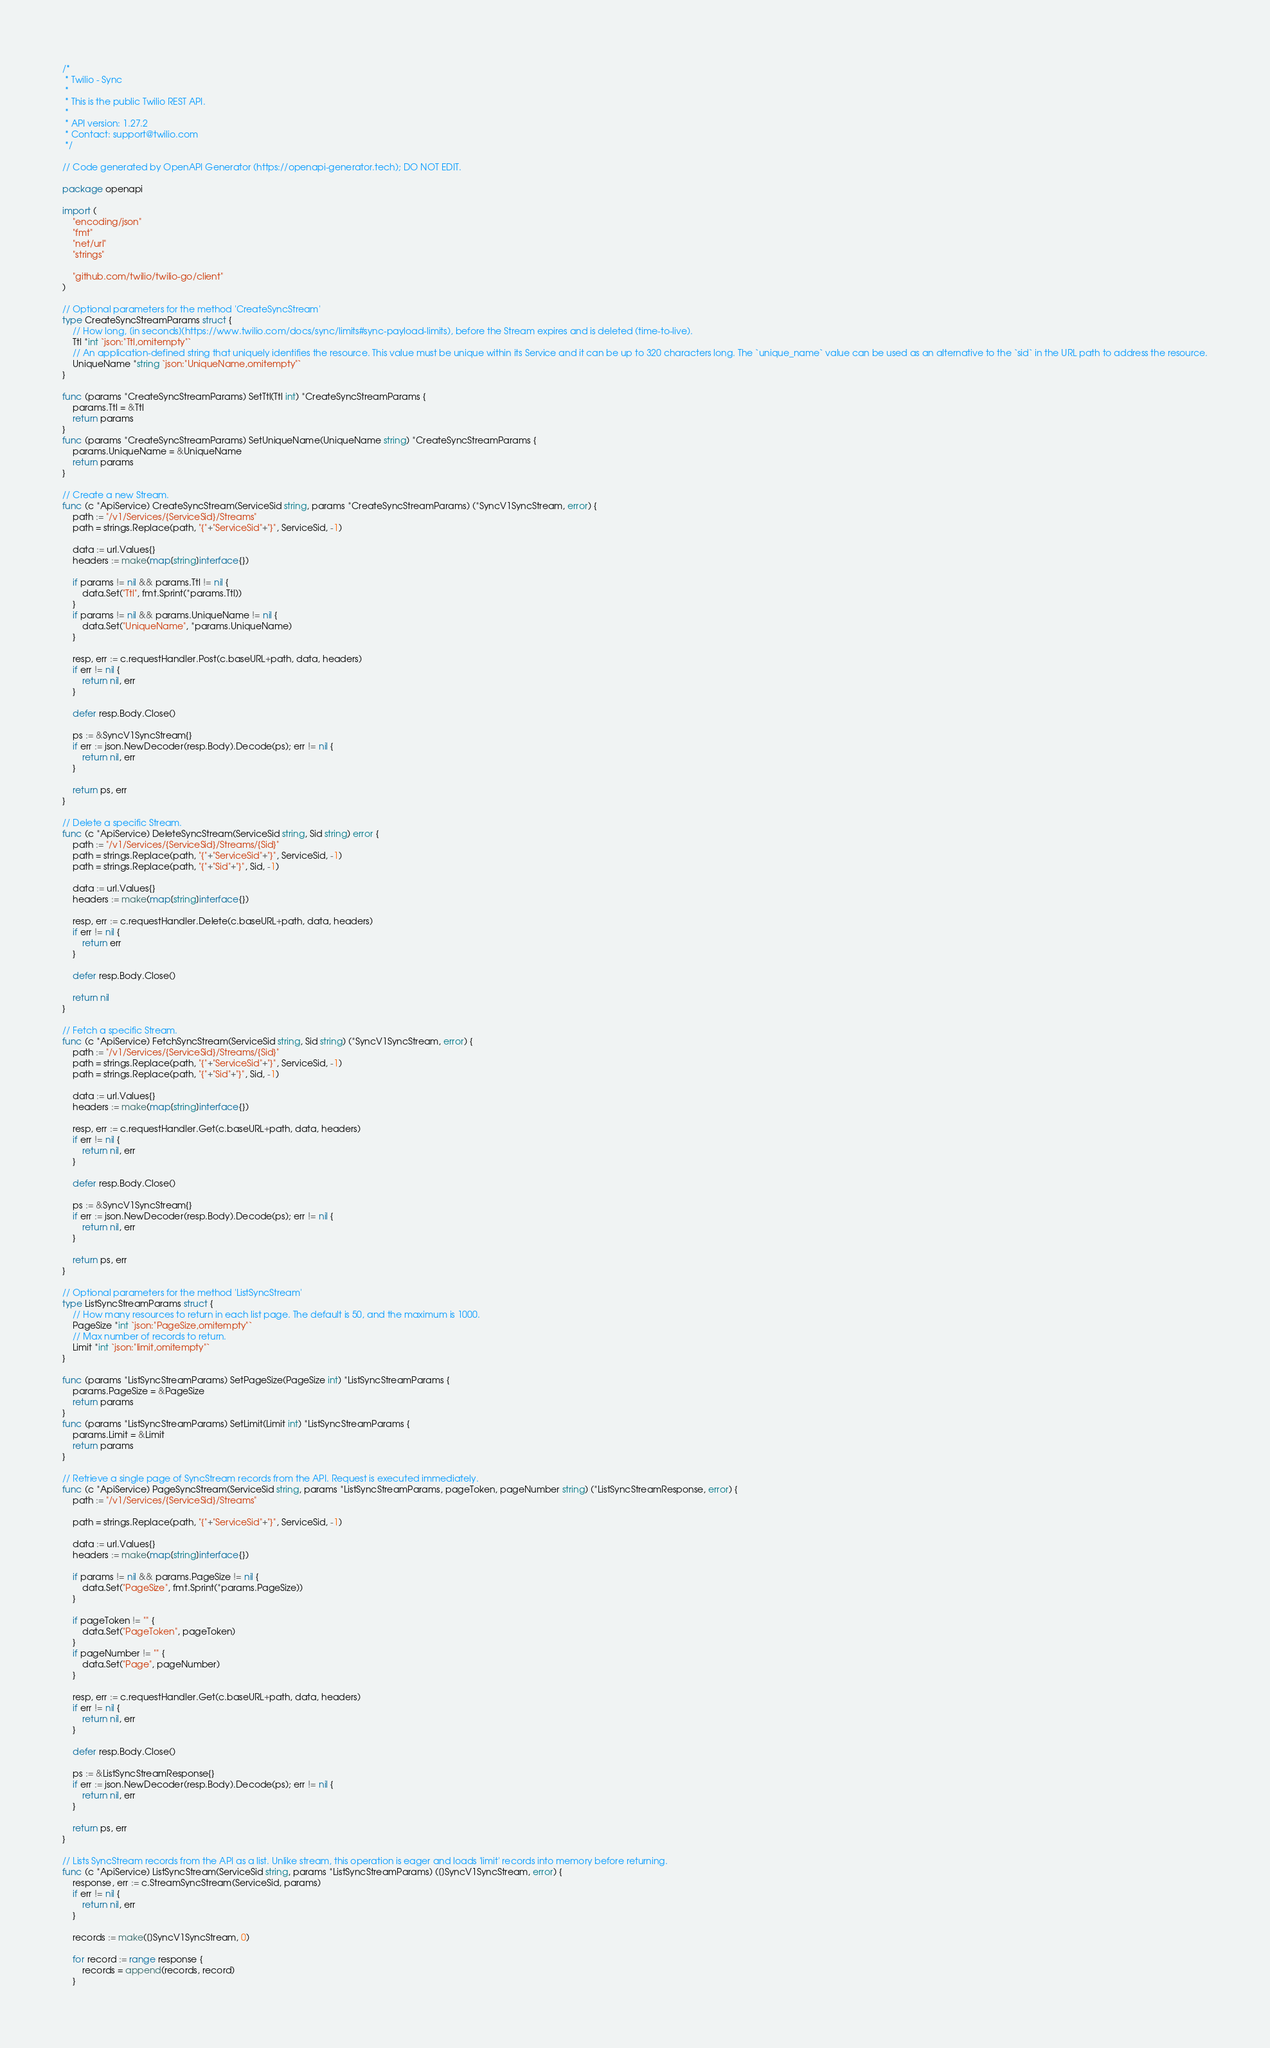<code> <loc_0><loc_0><loc_500><loc_500><_Go_>/*
 * Twilio - Sync
 *
 * This is the public Twilio REST API.
 *
 * API version: 1.27.2
 * Contact: support@twilio.com
 */

// Code generated by OpenAPI Generator (https://openapi-generator.tech); DO NOT EDIT.

package openapi

import (
	"encoding/json"
	"fmt"
	"net/url"
	"strings"

	"github.com/twilio/twilio-go/client"
)

// Optional parameters for the method 'CreateSyncStream'
type CreateSyncStreamParams struct {
	// How long, [in seconds](https://www.twilio.com/docs/sync/limits#sync-payload-limits), before the Stream expires and is deleted (time-to-live).
	Ttl *int `json:"Ttl,omitempty"`
	// An application-defined string that uniquely identifies the resource. This value must be unique within its Service and it can be up to 320 characters long. The `unique_name` value can be used as an alternative to the `sid` in the URL path to address the resource.
	UniqueName *string `json:"UniqueName,omitempty"`
}

func (params *CreateSyncStreamParams) SetTtl(Ttl int) *CreateSyncStreamParams {
	params.Ttl = &Ttl
	return params
}
func (params *CreateSyncStreamParams) SetUniqueName(UniqueName string) *CreateSyncStreamParams {
	params.UniqueName = &UniqueName
	return params
}

// Create a new Stream.
func (c *ApiService) CreateSyncStream(ServiceSid string, params *CreateSyncStreamParams) (*SyncV1SyncStream, error) {
	path := "/v1/Services/{ServiceSid}/Streams"
	path = strings.Replace(path, "{"+"ServiceSid"+"}", ServiceSid, -1)

	data := url.Values{}
	headers := make(map[string]interface{})

	if params != nil && params.Ttl != nil {
		data.Set("Ttl", fmt.Sprint(*params.Ttl))
	}
	if params != nil && params.UniqueName != nil {
		data.Set("UniqueName", *params.UniqueName)
	}

	resp, err := c.requestHandler.Post(c.baseURL+path, data, headers)
	if err != nil {
		return nil, err
	}

	defer resp.Body.Close()

	ps := &SyncV1SyncStream{}
	if err := json.NewDecoder(resp.Body).Decode(ps); err != nil {
		return nil, err
	}

	return ps, err
}

// Delete a specific Stream.
func (c *ApiService) DeleteSyncStream(ServiceSid string, Sid string) error {
	path := "/v1/Services/{ServiceSid}/Streams/{Sid}"
	path = strings.Replace(path, "{"+"ServiceSid"+"}", ServiceSid, -1)
	path = strings.Replace(path, "{"+"Sid"+"}", Sid, -1)

	data := url.Values{}
	headers := make(map[string]interface{})

	resp, err := c.requestHandler.Delete(c.baseURL+path, data, headers)
	if err != nil {
		return err
	}

	defer resp.Body.Close()

	return nil
}

// Fetch a specific Stream.
func (c *ApiService) FetchSyncStream(ServiceSid string, Sid string) (*SyncV1SyncStream, error) {
	path := "/v1/Services/{ServiceSid}/Streams/{Sid}"
	path = strings.Replace(path, "{"+"ServiceSid"+"}", ServiceSid, -1)
	path = strings.Replace(path, "{"+"Sid"+"}", Sid, -1)

	data := url.Values{}
	headers := make(map[string]interface{})

	resp, err := c.requestHandler.Get(c.baseURL+path, data, headers)
	if err != nil {
		return nil, err
	}

	defer resp.Body.Close()

	ps := &SyncV1SyncStream{}
	if err := json.NewDecoder(resp.Body).Decode(ps); err != nil {
		return nil, err
	}

	return ps, err
}

// Optional parameters for the method 'ListSyncStream'
type ListSyncStreamParams struct {
	// How many resources to return in each list page. The default is 50, and the maximum is 1000.
	PageSize *int `json:"PageSize,omitempty"`
	// Max number of records to return.
	Limit *int `json:"limit,omitempty"`
}

func (params *ListSyncStreamParams) SetPageSize(PageSize int) *ListSyncStreamParams {
	params.PageSize = &PageSize
	return params
}
func (params *ListSyncStreamParams) SetLimit(Limit int) *ListSyncStreamParams {
	params.Limit = &Limit
	return params
}

// Retrieve a single page of SyncStream records from the API. Request is executed immediately.
func (c *ApiService) PageSyncStream(ServiceSid string, params *ListSyncStreamParams, pageToken, pageNumber string) (*ListSyncStreamResponse, error) {
	path := "/v1/Services/{ServiceSid}/Streams"

	path = strings.Replace(path, "{"+"ServiceSid"+"}", ServiceSid, -1)

	data := url.Values{}
	headers := make(map[string]interface{})

	if params != nil && params.PageSize != nil {
		data.Set("PageSize", fmt.Sprint(*params.PageSize))
	}

	if pageToken != "" {
		data.Set("PageToken", pageToken)
	}
	if pageNumber != "" {
		data.Set("Page", pageNumber)
	}

	resp, err := c.requestHandler.Get(c.baseURL+path, data, headers)
	if err != nil {
		return nil, err
	}

	defer resp.Body.Close()

	ps := &ListSyncStreamResponse{}
	if err := json.NewDecoder(resp.Body).Decode(ps); err != nil {
		return nil, err
	}

	return ps, err
}

// Lists SyncStream records from the API as a list. Unlike stream, this operation is eager and loads 'limit' records into memory before returning.
func (c *ApiService) ListSyncStream(ServiceSid string, params *ListSyncStreamParams) ([]SyncV1SyncStream, error) {
	response, err := c.StreamSyncStream(ServiceSid, params)
	if err != nil {
		return nil, err
	}

	records := make([]SyncV1SyncStream, 0)

	for record := range response {
		records = append(records, record)
	}
</code> 